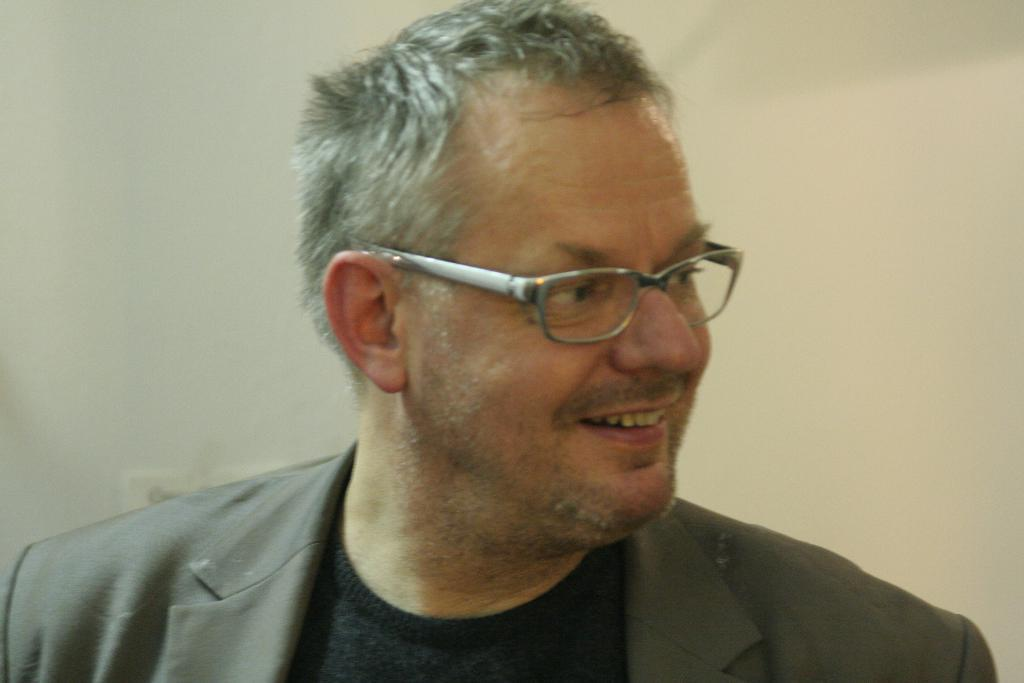Who is the main subject in the foreground of the image? There is a man in the foreground of the image. What is the man wearing? The man is wearing a suit. What can be seen in the background of the image? There is a white wall in the background of the image. What type of sign is the kitten holding in the image? There is no kitten or sign present in the image. How many lifts are visible in the image? There are no lifts visible in the image. 